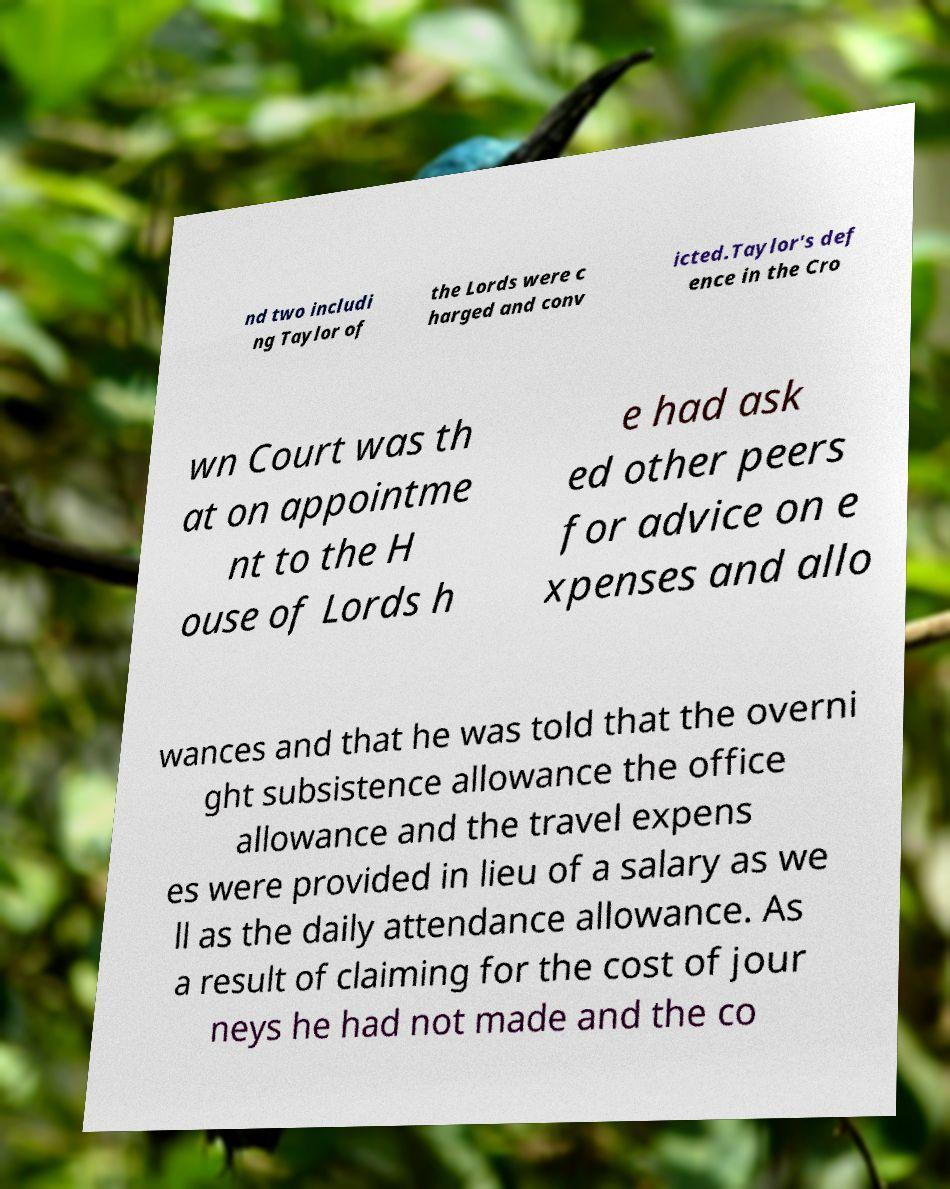Could you assist in decoding the text presented in this image and type it out clearly? nd two includi ng Taylor of the Lords were c harged and conv icted.Taylor's def ence in the Cro wn Court was th at on appointme nt to the H ouse of Lords h e had ask ed other peers for advice on e xpenses and allo wances and that he was told that the overni ght subsistence allowance the office allowance and the travel expens es were provided in lieu of a salary as we ll as the daily attendance allowance. As a result of claiming for the cost of jour neys he had not made and the co 